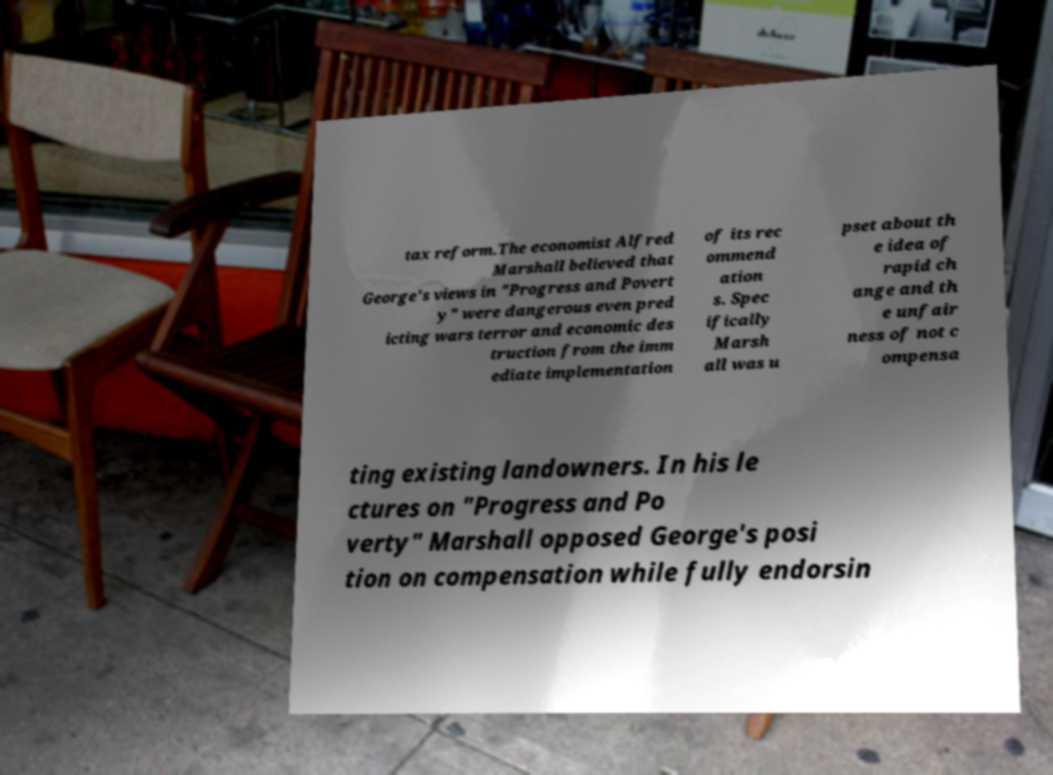What messages or text are displayed in this image? I need them in a readable, typed format. tax reform.The economist Alfred Marshall believed that George's views in "Progress and Povert y" were dangerous even pred icting wars terror and economic des truction from the imm ediate implementation of its rec ommend ation s. Spec ifically Marsh all was u pset about th e idea of rapid ch ange and th e unfair ness of not c ompensa ting existing landowners. In his le ctures on "Progress and Po verty" Marshall opposed George's posi tion on compensation while fully endorsin 